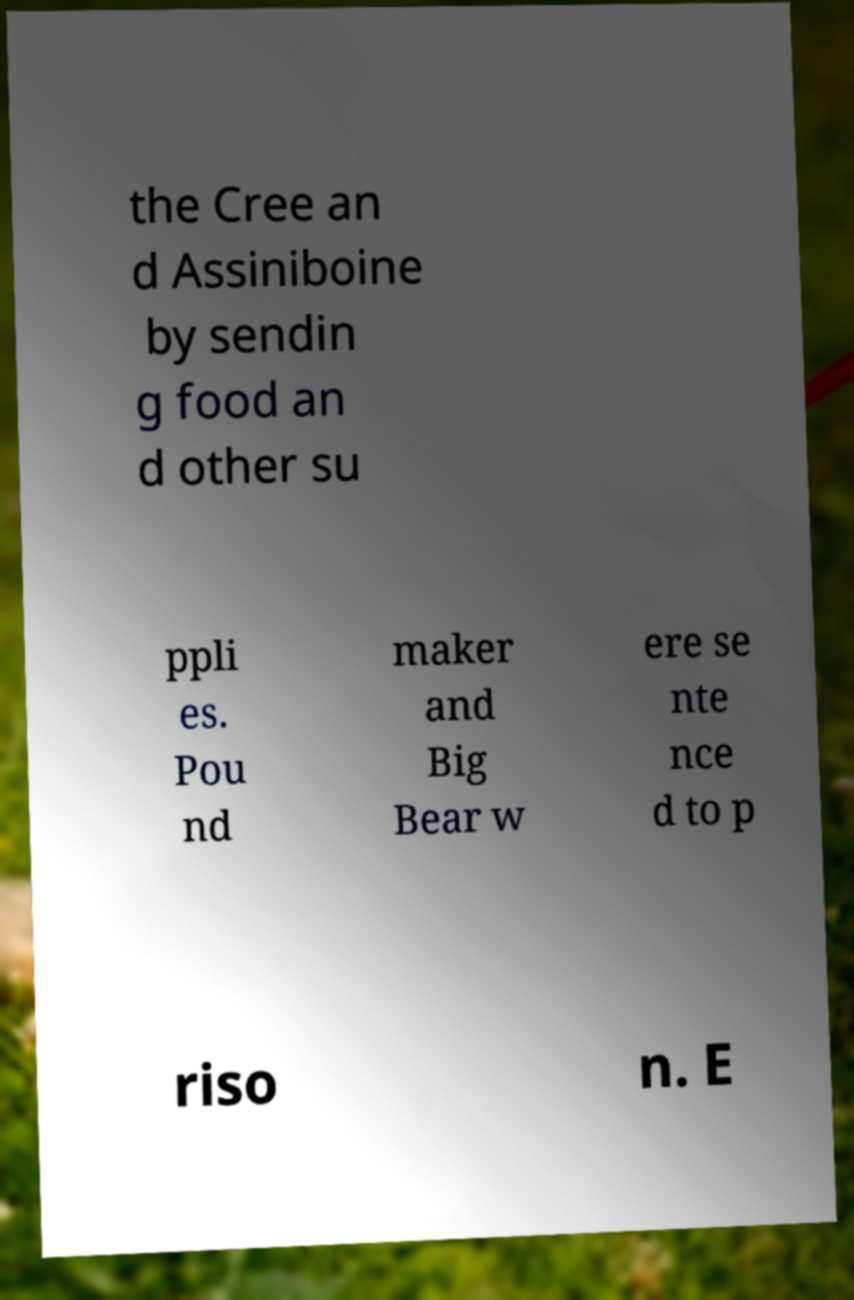Could you assist in decoding the text presented in this image and type it out clearly? the Cree an d Assiniboine by sendin g food an d other su ppli es. Pou nd maker and Big Bear w ere se nte nce d to p riso n. E 